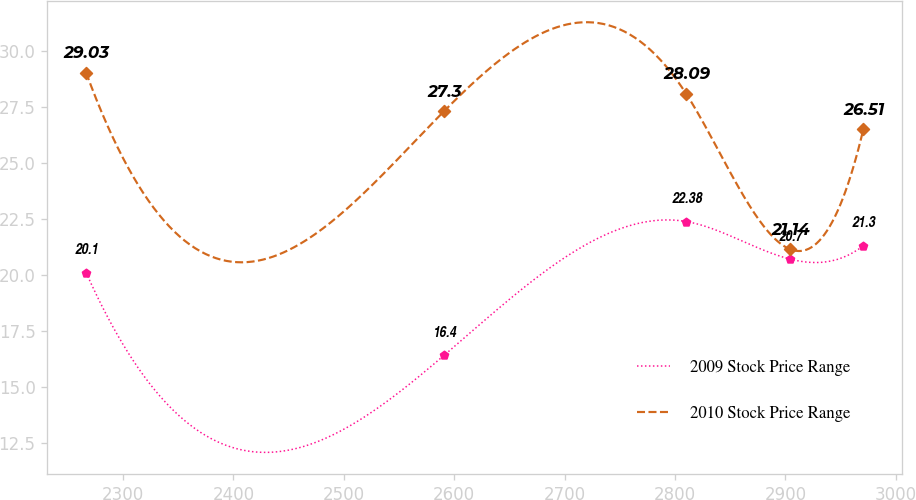<chart> <loc_0><loc_0><loc_500><loc_500><line_chart><ecel><fcel>2009 Stock Price Range<fcel>2010 Stock Price Range<nl><fcel>2266.51<fcel>20.1<fcel>29.03<nl><fcel>2590.67<fcel>16.4<fcel>27.3<nl><fcel>2809.97<fcel>22.38<fcel>28.09<nl><fcel>2904.33<fcel>20.7<fcel>21.14<nl><fcel>2970.61<fcel>21.3<fcel>26.51<nl></chart> 